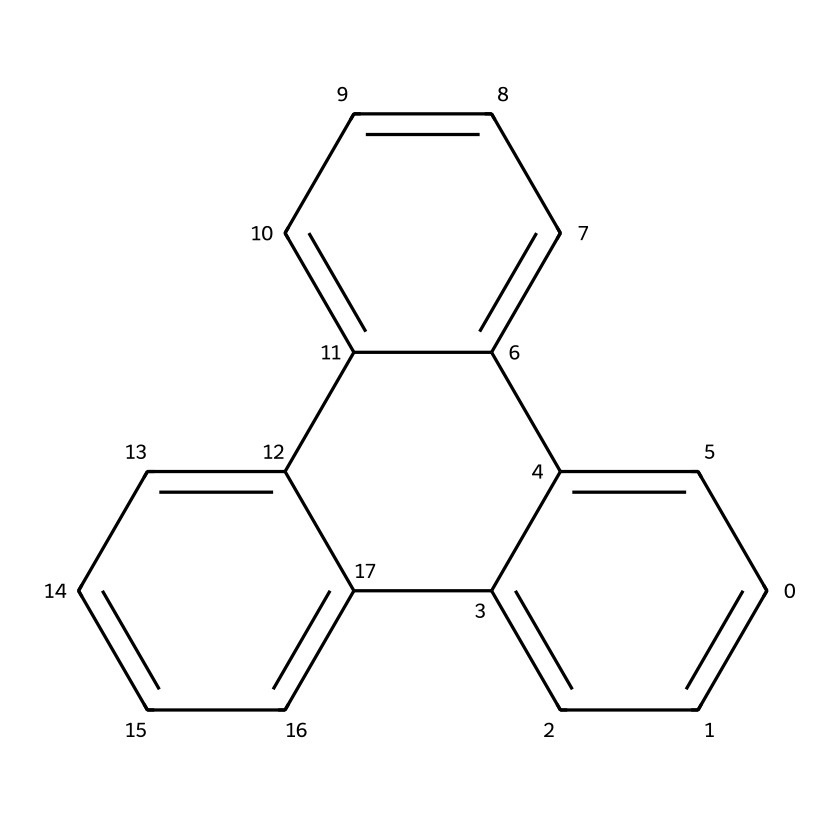What is the name of this chemical? The SMILES representation indicates a polycyclic aromatic hydrocarbon with multiple interconnected aromatic rings, specifically identified as triphenylene.
Answer: triphenylene How many benzene rings are present in this chemical? By analyzing the structure depicted in the SMILES, there are four benzene rings due to the presence of multiple interconnected carbon atoms forming distinct ring structures.
Answer: four What is the total number of carbon atoms in this compound? Counting the carbon atoms based on the structure derived from the SMILES shows there are 18 carbon atoms, as calculated from the individual rings and connectivity.
Answer: 18 Does this molecule exhibit planar conformation? The structure of polycyclic aromatic hydrocarbons like triphenylene typically exhibits a planar conformation due to the sp2 hybridization of carbon and resonance stability.
Answer: yes What is the primary type of chemical bonding present in this chemical? This compound is comprised predominantly of covalent bonding between carbon atoms, specifically pi bonds that form due to the overlap of p orbitals in the aromatic rings.
Answer: covalent What property makes this chemical potentially toxic? The presence of multiple fused aromatic rings can lead to a high degree of stability, but also to the formation of reactive intermediates during metabolism, making it potentially carcinogenic.
Answer: carcinogenic How does this compound interact with light? As a polycyclic aromatic hydrocarbon, it can absorb ultraviolet light due to its conjugated pi electron system, leading to excitation of electrons and potentially causing phototoxicity.
Answer: absorbs ultraviolet light 